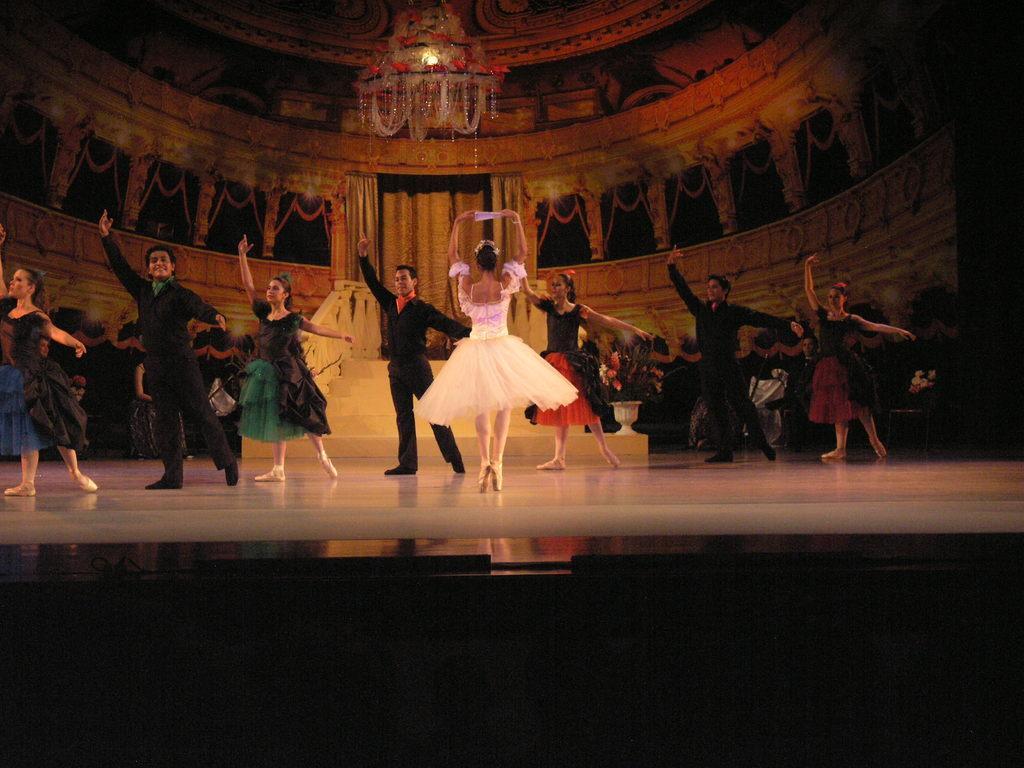Please provide a concise description of this image. As we can see in the image there are few people dancing, chandelier, stairs and a wall. 